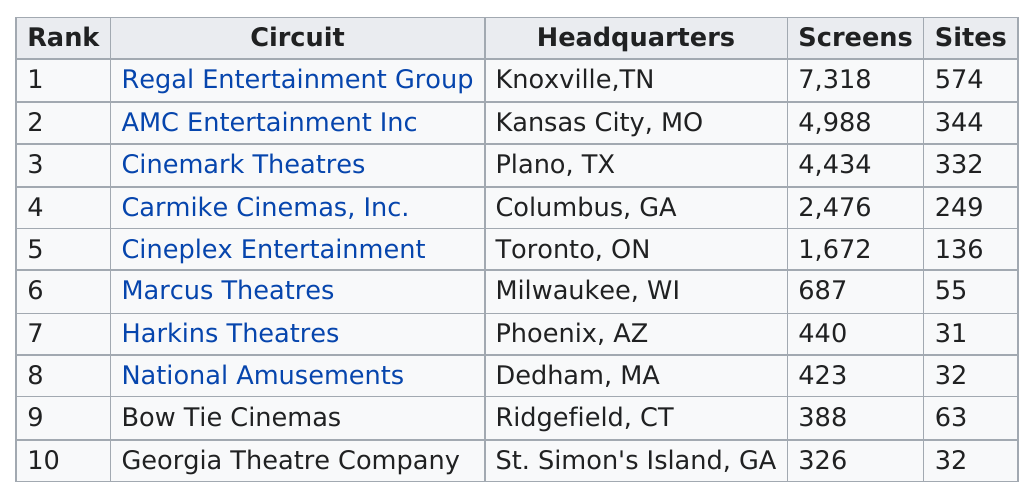Draw attention to some important aspects in this diagram. Georgia Theatre Company has fewer screens than Bow Tie Cinemas. Regal Entertainment Group has the top ranking circuit in terms of total number of sites. Regal Entertainment Group, which has the largest number of screens, is a leading cinema company in the United States. Georgia Theatre Company has the least amount of screens out of all circuits. Cineplex Entertainment is ranked after Marcus Theatres in terms of circuit size. 